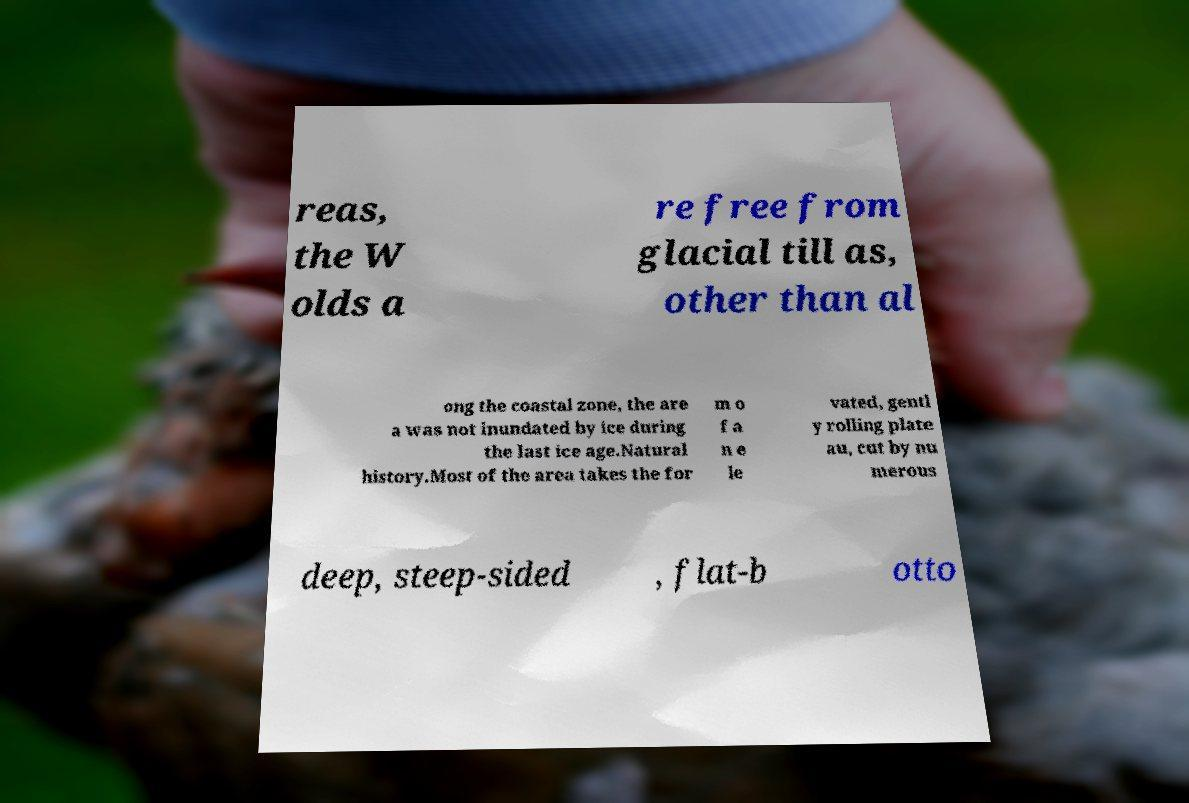For documentation purposes, I need the text within this image transcribed. Could you provide that? reas, the W olds a re free from glacial till as, other than al ong the coastal zone, the are a was not inundated by ice during the last ice age.Natural history.Most of the area takes the for m o f a n e le vated, gentl y rolling plate au, cut by nu merous deep, steep-sided , flat-b otto 